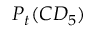Convert formula to latex. <formula><loc_0><loc_0><loc_500><loc_500>P _ { t } ( C D _ { 5 } )</formula> 